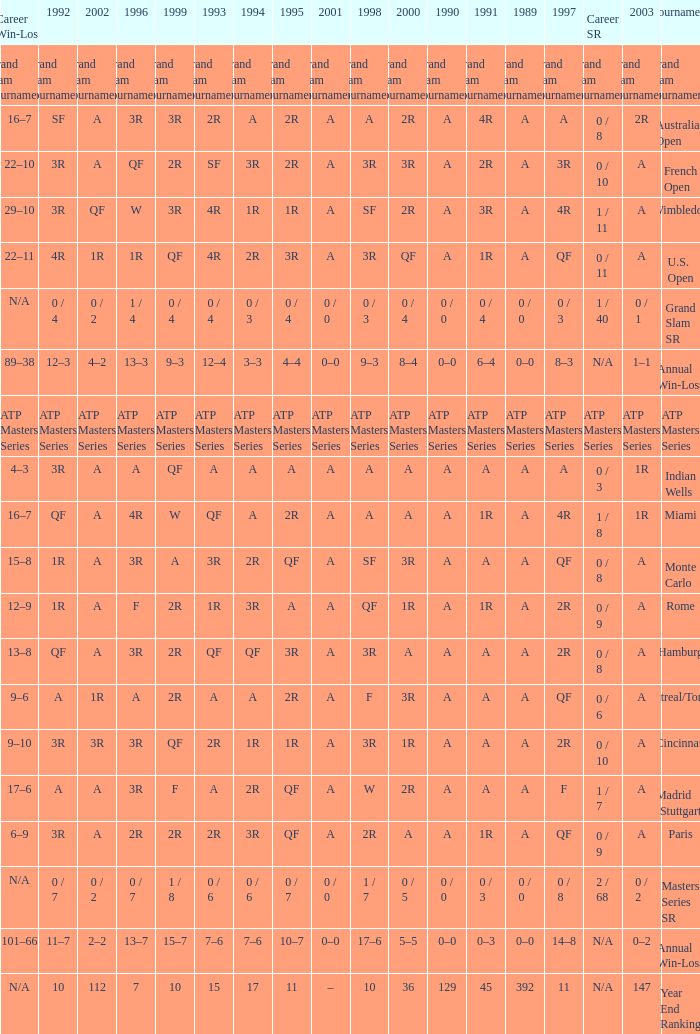What was the value in 1995 for A in 2000 at the Indian Wells tournament? A. 